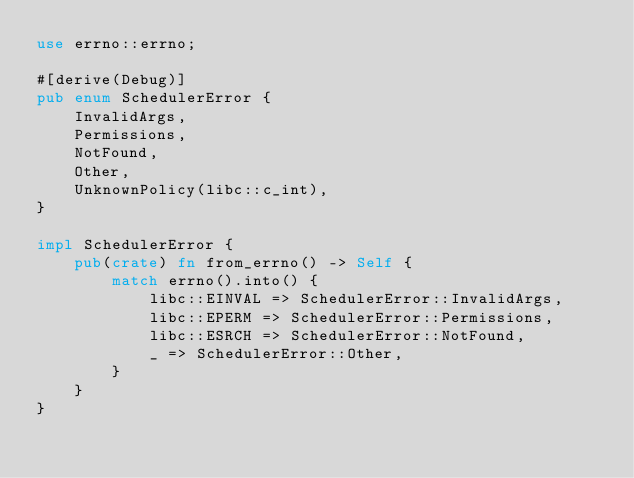<code> <loc_0><loc_0><loc_500><loc_500><_Rust_>use errno::errno;

#[derive(Debug)]
pub enum SchedulerError {
    InvalidArgs,
    Permissions,
    NotFound,
    Other,
    UnknownPolicy(libc::c_int),
}

impl SchedulerError {
    pub(crate) fn from_errno() -> Self {
        match errno().into() {
            libc::EINVAL => SchedulerError::InvalidArgs,
            libc::EPERM => SchedulerError::Permissions,
            libc::ESRCH => SchedulerError::NotFound,
            _ => SchedulerError::Other,
        }
    }
}
</code> 